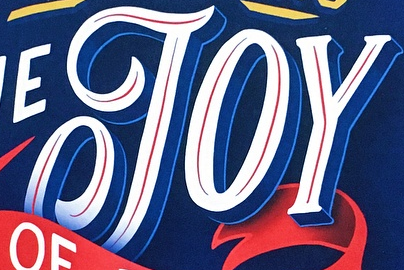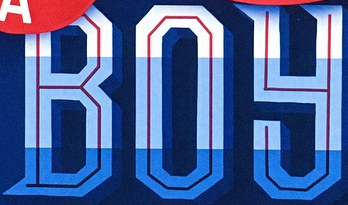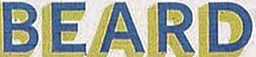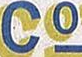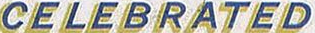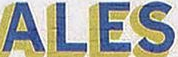What text is displayed in these images sequentially, separated by a semicolon? JOY; BOY; BEARD; Co; CELEBRATED; ALES 